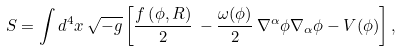Convert formula to latex. <formula><loc_0><loc_0><loc_500><loc_500>S = \int d ^ { 4 } x \, \sqrt { - g } \left [ \frac { f \left ( \phi , R \right ) } { 2 } \, - \frac { \omega ( \phi ) } { 2 } \, \nabla ^ { \alpha } \phi \nabla _ { \alpha } \phi - V ( \phi ) \right ] ,</formula> 